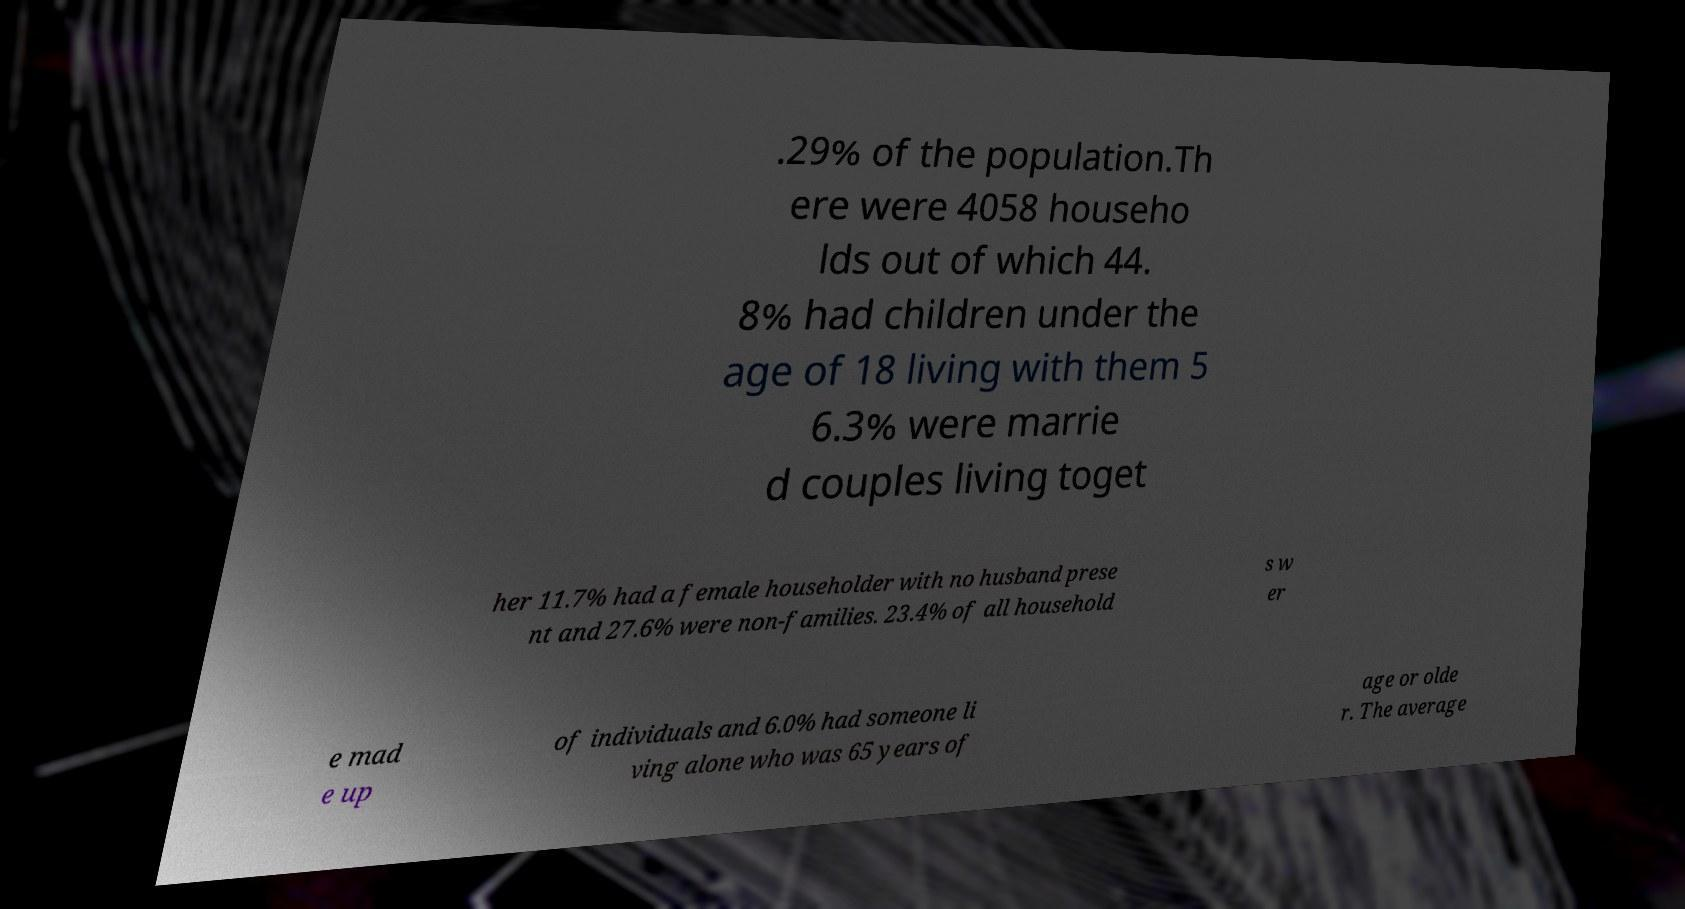Could you extract and type out the text from this image? .29% of the population.Th ere were 4058 househo lds out of which 44. 8% had children under the age of 18 living with them 5 6.3% were marrie d couples living toget her 11.7% had a female householder with no husband prese nt and 27.6% were non-families. 23.4% of all household s w er e mad e up of individuals and 6.0% had someone li ving alone who was 65 years of age or olde r. The average 